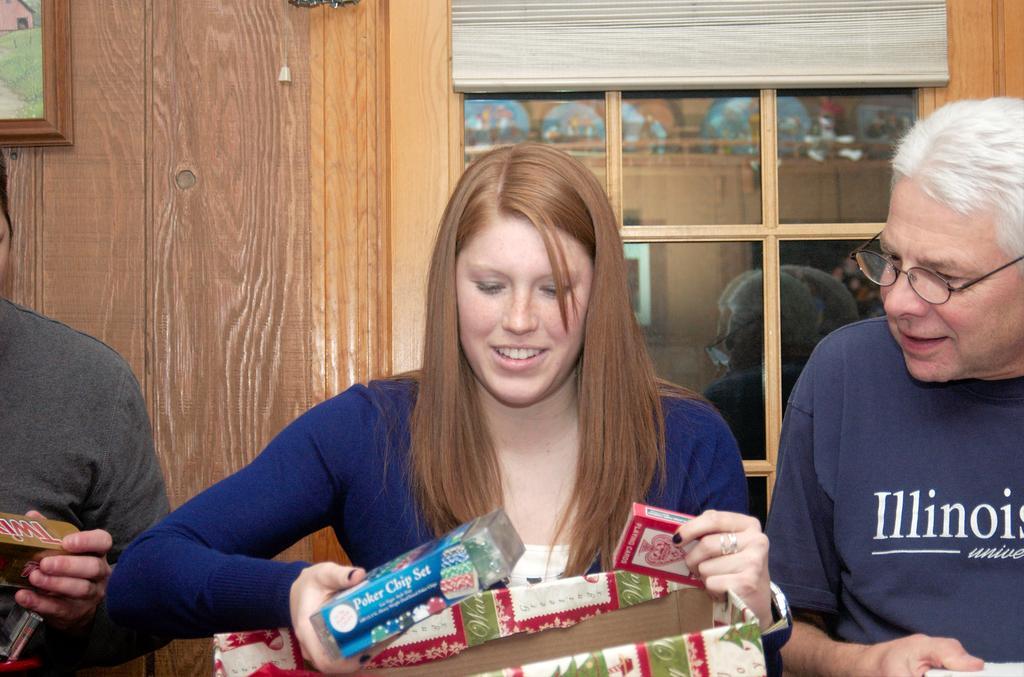In one or two sentences, can you explain what this image depicts? In the foreground of this image, there is a woman holding two boxes and also a cardboard box at the bottom. on either side to her, there are two men holding boxes. Behind them, there is a wooden wall, frame and a window. 